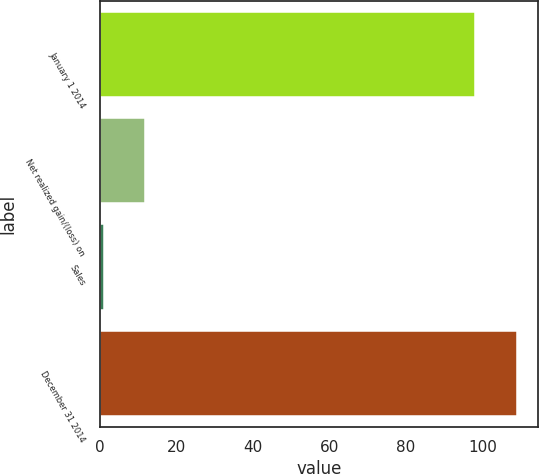Convert chart to OTSL. <chart><loc_0><loc_0><loc_500><loc_500><bar_chart><fcel>January 1 2014<fcel>Net realized gain/(loss) on<fcel>Sales<fcel>December 31 2014<nl><fcel>98<fcel>11.8<fcel>1<fcel>109<nl></chart> 